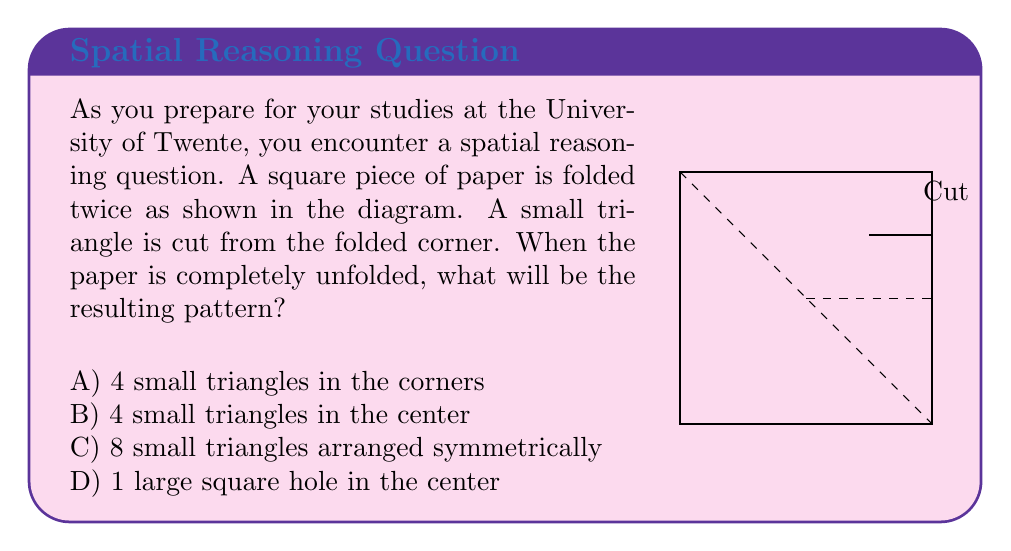Give your solution to this math problem. Let's approach this step-by-step:

1) First, we need to understand the folding process:
   - The square is folded diagonally once (from corner to corner).
   - Then it's folded in half again, creating a smaller triangle.

2) The cut is made on the corner of this smaller triangle.

3) To visualize the unfolding process, let's consider each fold:
   - When we unfold the second fold, the cut will create two identical triangles on opposite corners of the larger folded triangle.
   - When we unfold the first (diagonal) fold, these two triangles will be mirrored across the diagonal, creating four triangles in total.

4) The key is to understand that each cut creates a symmetrical pattern when unfolded.

5) In this case, the four triangles will be located in the corners of the original square, not in the center.

6) The size of these triangles will be small relative to the original square, as the cut was made on a twice-folded paper.

Therefore, when completely unfolded, the paper will have 4 small triangles, one in each corner of the square.
Answer: A) 4 small triangles in the corners 